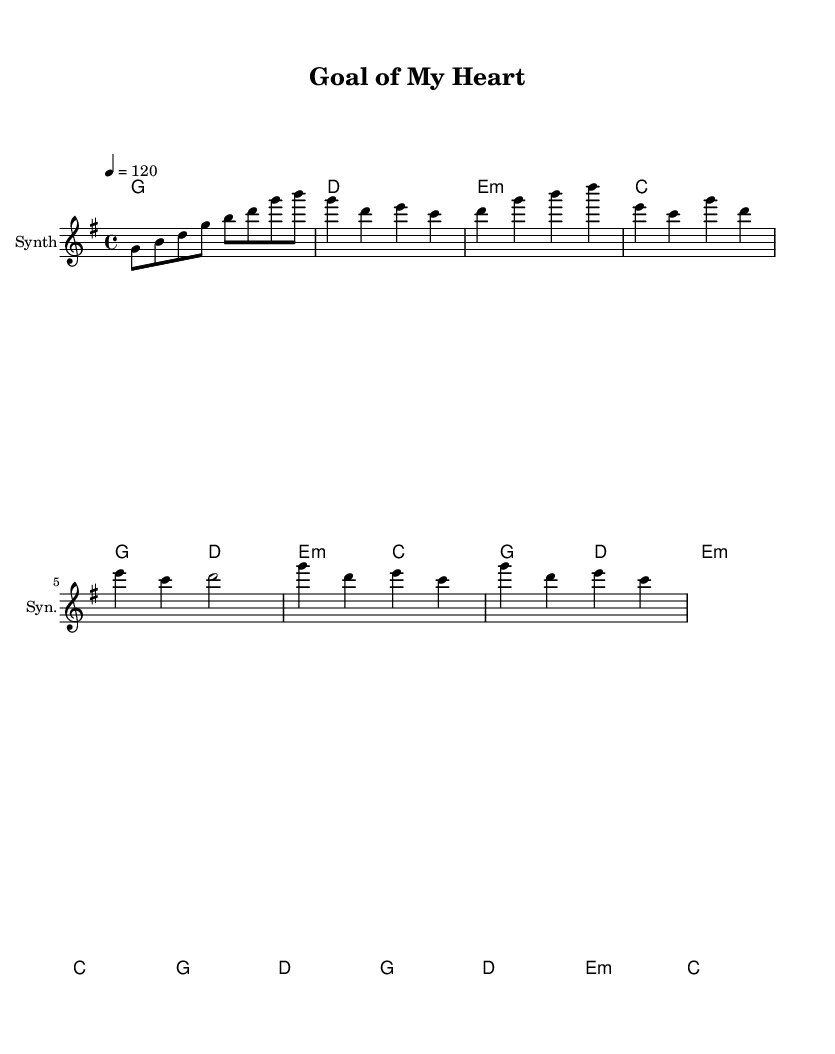What is the key signature of this music? The key signature is G major, which has one sharp (F#).
Answer: G major What is the time signature of this piece? The time signature is 4/4, indicating four beats in each measure.
Answer: 4/4 What is the tempo of the music? The tempo is marked at 120 beats per minute, indicated by the note under tempo.
Answer: 120 What is the first chord in the introduction? The first chord in the introduction is a G major chord, as indicated in the harmonies section.
Answer: G major How many measures are in the verse section? The verse section consists of three measures as shown in the melody line.
Answer: 3 Which section has a different chord progression compared to the verse? The pre-chorus has a different progression, featuring minor chords and changes that contrast with the verse.
Answer: Pre-Chorus What type of instrument is denoted for the staff? The staff indicates that the instrument is a synthesizer, as specified in the instrument name.
Answer: Synth 